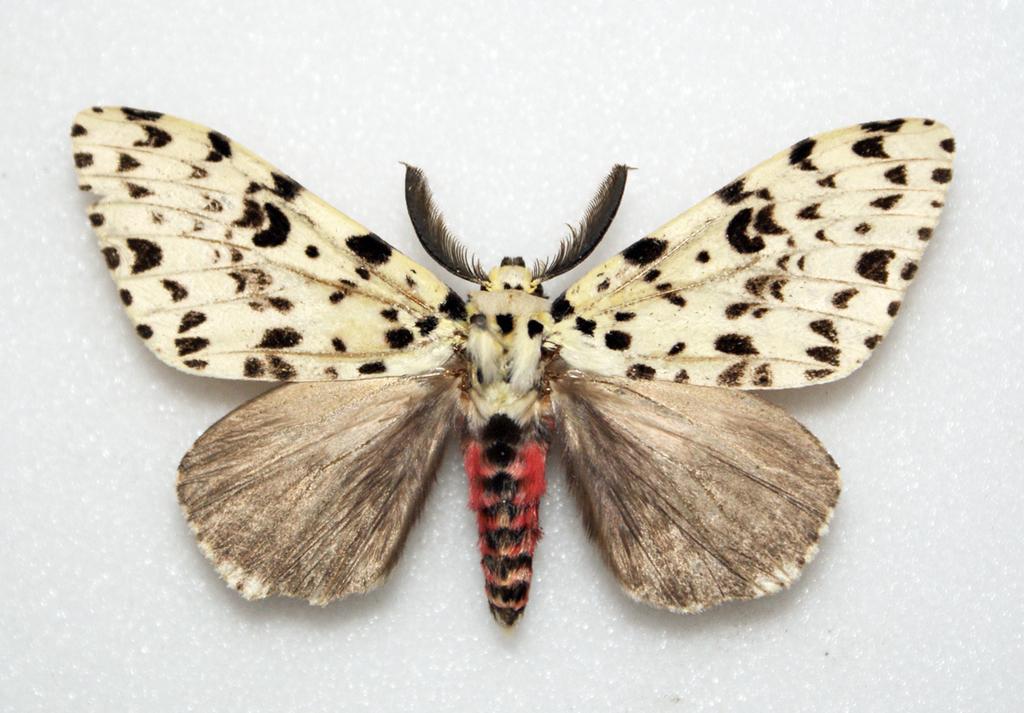Please provide a concise description of this image. In this image we can see butterfly which is in multi color like white, red, black. 